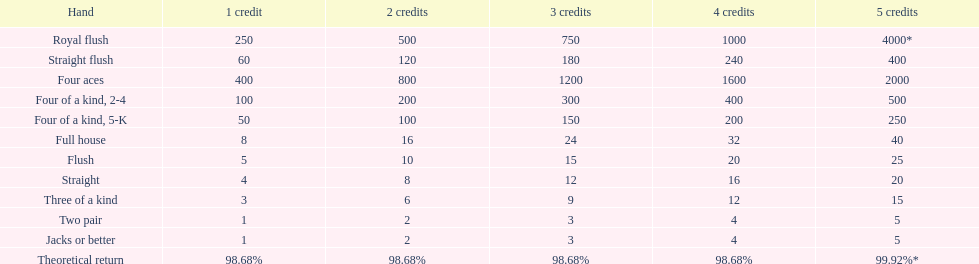Could you help me parse every detail presented in this table? {'header': ['Hand', '1 credit', '2 credits', '3 credits', '4 credits', '5 credits'], 'rows': [['Royal flush', '250', '500', '750', '1000', '4000*'], ['Straight flush', '60', '120', '180', '240', '400'], ['Four aces', '400', '800', '1200', '1600', '2000'], ['Four of a kind, 2-4', '100', '200', '300', '400', '500'], ['Four of a kind, 5-K', '50', '100', '150', '200', '250'], ['Full house', '8', '16', '24', '32', '40'], ['Flush', '5', '10', '15', '20', '25'], ['Straight', '4', '8', '12', '16', '20'], ['Three of a kind', '3', '6', '9', '12', '15'], ['Two pair', '1', '2', '3', '4', '5'], ['Jacks or better', '1', '2', '3', '4', '5'], ['Theoretical return', '98.68%', '98.68%', '98.68%', '98.68%', '99.92%*']]} For every win with four aces, what number is a multiple? 400. 